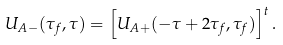Convert formula to latex. <formula><loc_0><loc_0><loc_500><loc_500>U _ { A - } ( \tau _ { f } , \tau ) = \left [ U _ { A + } ( - \tau + 2 \tau _ { f } , \tau _ { f } ) \right ] ^ { t } .</formula> 